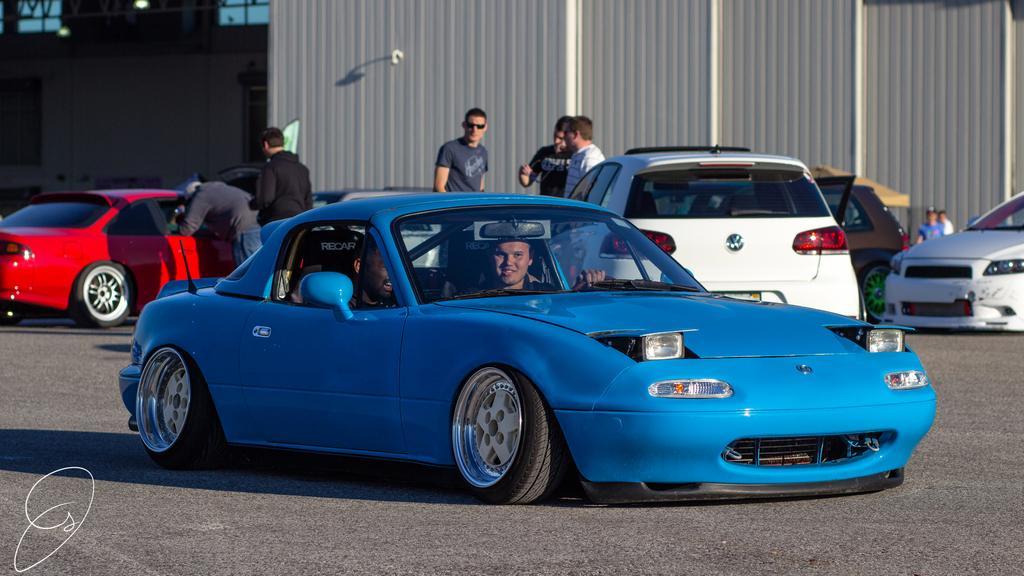In one or two sentences, can you explain what this image depicts? In this image I can see people among them some are standing and some are in cars. In the background I can see a wall and some other object on the ground. Here I can see a watermark on the image. 